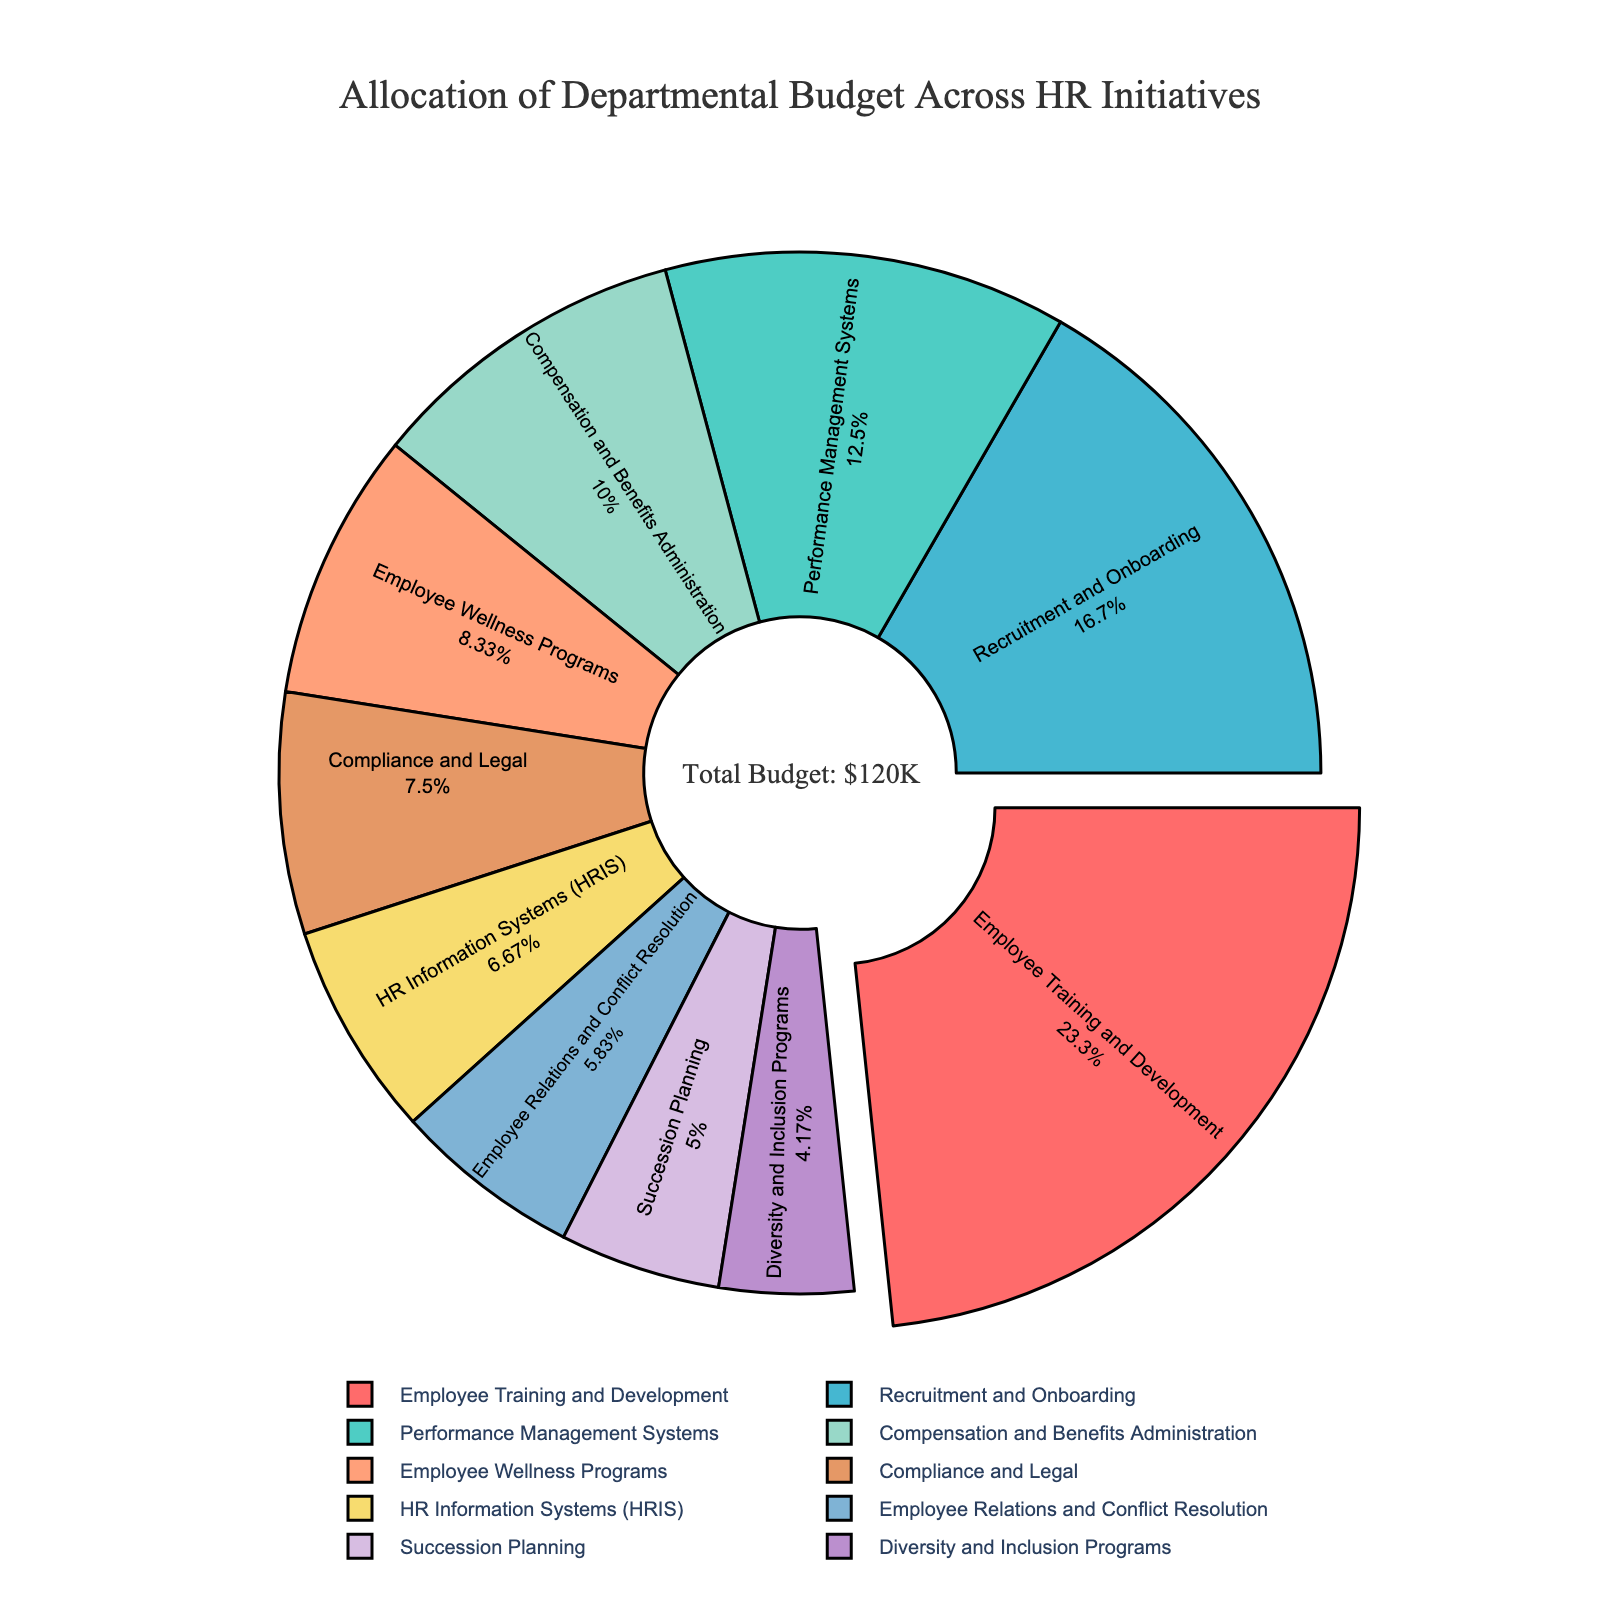What percentage of the budget is allocated to Employee Training and Development? The pie chart shows that Employee Training and Development occupies the largest segment, which is pulled out slightly. The text inside this segment shows "28% Employee Training and Development" which directly gives the percentage.
Answer: 28% What is the combined budget allocation for Recruitment and Onboarding and Compensation and Benefits Administration? To find the combined allocation, add the percentages for Recruitment and Onboarding and Compensation and Benefits Administration. According to the pie chart, Recruitment and Onboarding is 20% and Compensation and Benefits Administration is 12%. So, 20% + 12% = 32%.
Answer: 32% Which HR initiative has the smallest budget allocation, and what is its percentage? The smallest segment in the pie chart represents Diversity and Inclusion Programs. The text within this slice shows that it is 5%.
Answer: Diversity and Inclusion Programs, 5% Is the budget allocated to Employee Wellness Programs greater than or equal to that for Compliance and Legal? Look at the pie chart segments for Employee Wellness Programs and Compliance and Legal. Employee Wellness Programs is 10%, and Compliance and Legal is 9%. Since 10% is greater than 9%, the answer is yes.
Answer: Yes What are the top three initiatives in terms of budget allocation? Identify the three largest segments in the pie chart. Employee Training and Development (28%), Recruitment and Onboarding (20%), and Performance Management Systems (15%) are the top three initiatives.
Answer: Employee Training and Development, Recruitment and Onboarding, Performance Management Systems How much more is allocated to Performance Management Systems compared to HR Information Systems (HRIS)? Subtract the percentage of HR Information Systems (HRIS) from Performance Management Systems. Performance Management Systems is 15% and HR Information Systems (HRIS) is 8%. So, 15% - 8% = 7%.
Answer: 7% What is the average budget allocation for Employee Relations and Conflict Resolution, Compliance and Legal, and Succession Planning? Add the percentages of these three initiatives and divide by 3. Employee Relations and Conflict Resolution is 7%, Compliance and Legal is 9%, and Succession Planning is 6%. (7% + 9% + 6%) / 3 = 22% / 3 ≈ 7.33%.
Answer: 7.33% How much total budget (in K) is allocated to Employee Wellness Programs and Succession Planning? Convert the percentages to absolute values using the total budget of $120K (sum of all percentages as 100% * $120K = $120K), then add the two values. Employee Wellness Programs is 10% of $120K which is $12K, and Succession Planning is 6% of $120K which is $7.2K. So, $12K + $7.2K = $19.2K.
Answer: $19.2K 